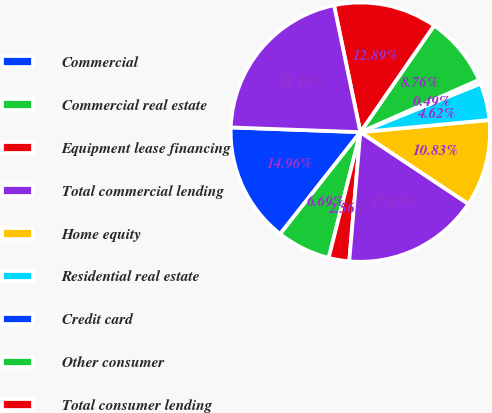<chart> <loc_0><loc_0><loc_500><loc_500><pie_chart><fcel>Commercial<fcel>Commercial real estate<fcel>Equipment lease financing<fcel>Total commercial lending<fcel>Home equity<fcel>Residential real estate<fcel>Credit card<fcel>Other consumer<fcel>Total consumer lending<fcel>Total loans<nl><fcel>14.96%<fcel>6.69%<fcel>2.56%<fcel>17.03%<fcel>10.83%<fcel>4.62%<fcel>0.49%<fcel>8.76%<fcel>12.89%<fcel>21.16%<nl></chart> 